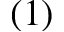<formula> <loc_0><loc_0><loc_500><loc_500>( 1 )</formula> 